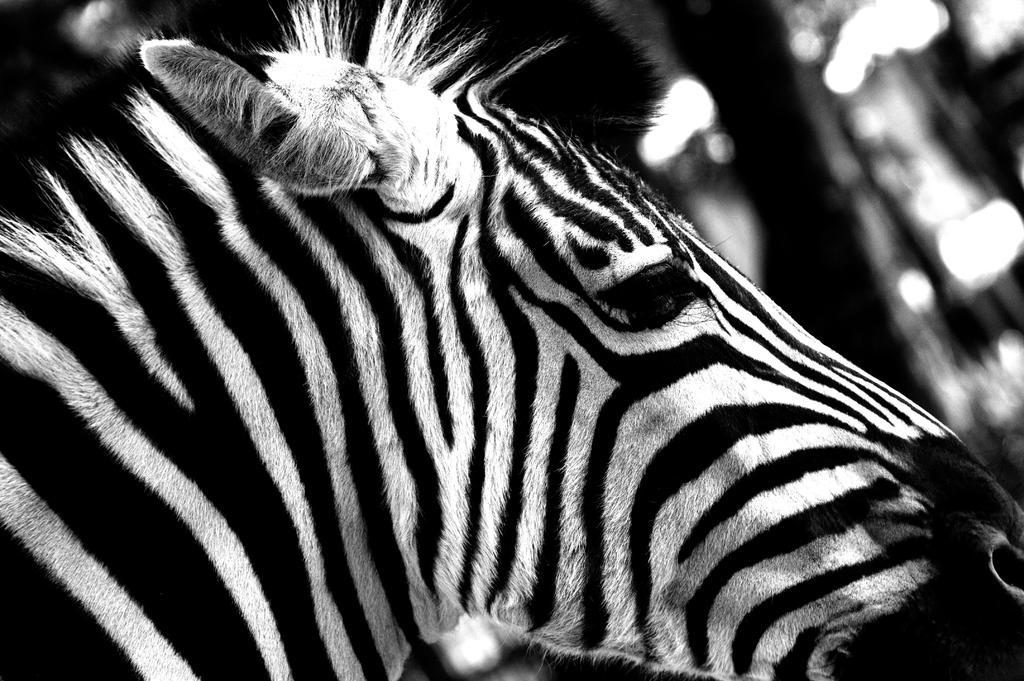In one or two sentences, can you explain what this image depicts? In the picture I can see a zebra. The background of the image is blurred. This image is black and white in color. 